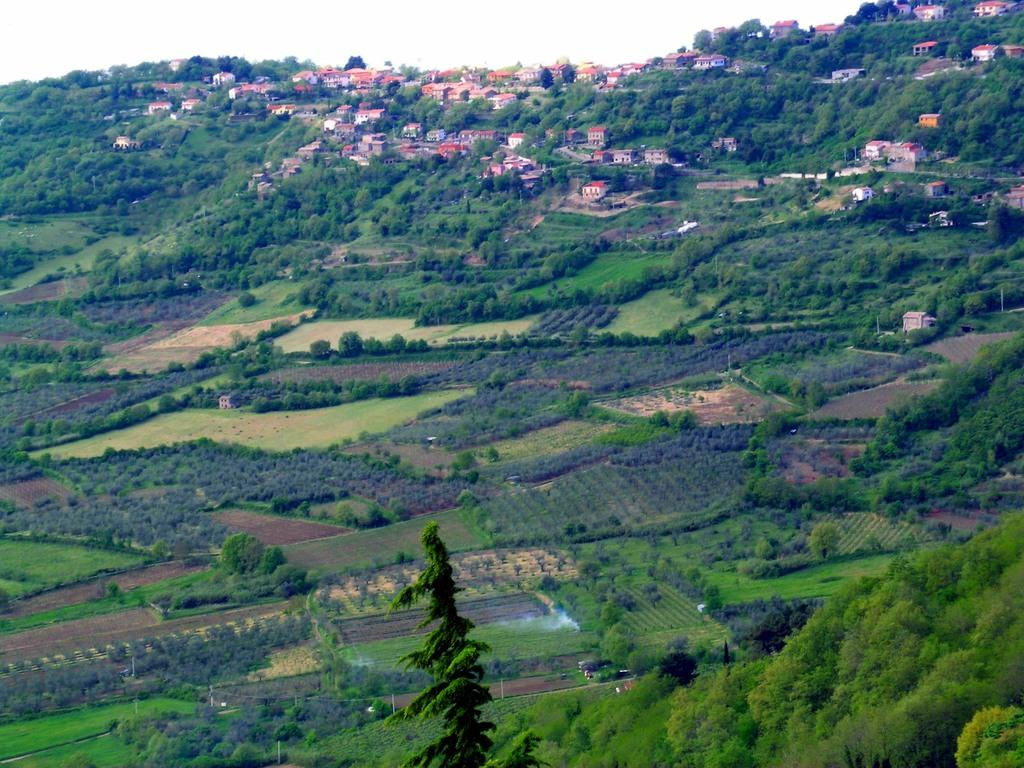What type of landscape is depicted in the image? The image features fields, trees, and buildings. Can you describe the natural elements in the image? There are trees in the image. What can be seen in the background of the image? The sky is visible in the image. What type of flower is growing in the wilderness in the image? There is no wilderness or flower present in the image; it features fields, trees, and buildings. Can you tell me the name of the secretary working in the building in the image? There is no secretary or building interior visible in the image; it only shows the exterior of the buildings. 